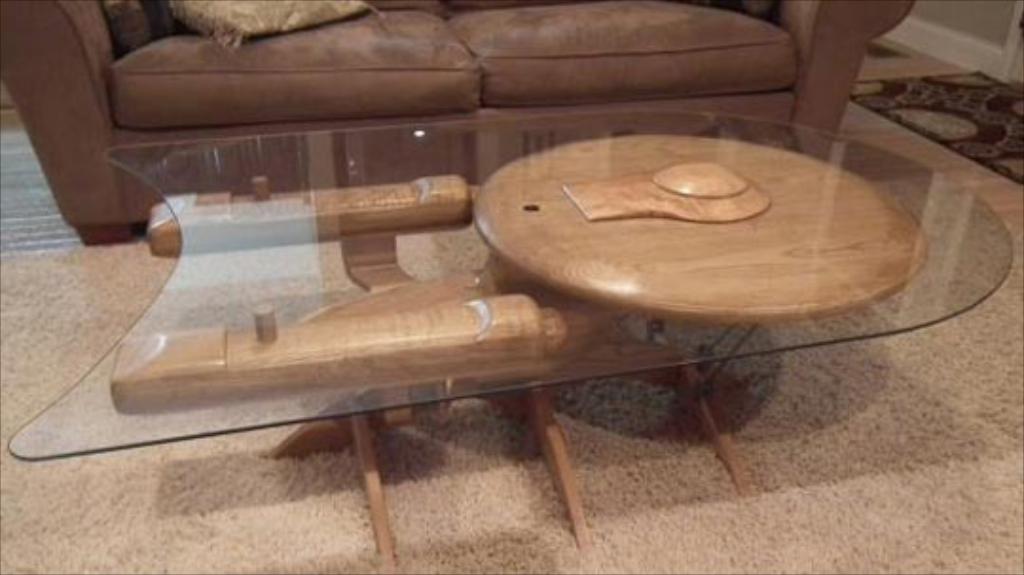Describe this image in one or two sentences. This image consists of a sofa at the top. There is a table in the middle. It is made from glass. There is a carpet at the bottom. 